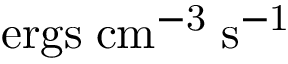<formula> <loc_0><loc_0><loc_500><loc_500>e r g s \, c m ^ { - 3 } \, s ^ { - 1 }</formula> 